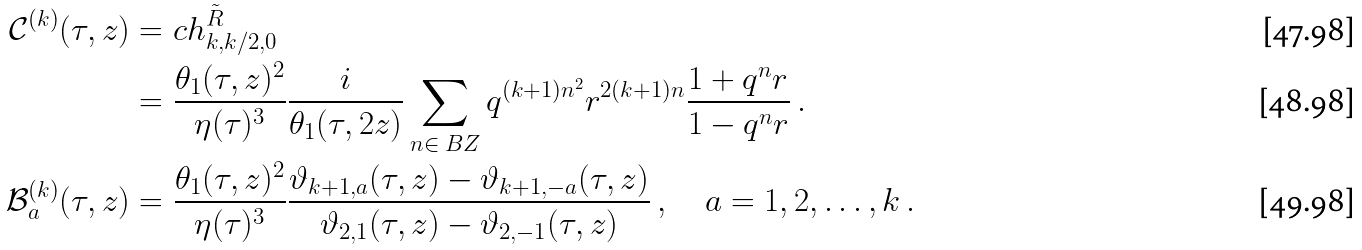Convert formula to latex. <formula><loc_0><loc_0><loc_500><loc_500>\mathcal { C } ^ { ( k ) } ( \tau , z ) & = c h ^ { \tilde { R } } _ { k , k / 2 , 0 } \\ & = \frac { \theta _ { 1 } ( \tau , z ) ^ { 2 } } { \eta ( \tau ) ^ { 3 } } \frac { i } { \theta _ { 1 } ( \tau , 2 z ) } \sum _ { n \in \ B Z } q ^ { ( k + 1 ) n ^ { 2 } } r ^ { 2 ( k + 1 ) n } \frac { 1 + q ^ { n } r } { 1 - q ^ { n } r } \ . \\ \mathcal { B } _ { a } ^ { ( k ) } ( \tau , z ) & = \frac { \theta _ { 1 } ( \tau , z ) ^ { 2 } } { \eta ( \tau ) ^ { 3 } } \frac { \vartheta _ { k + 1 , a } ( \tau , z ) - \vartheta _ { k + 1 , - a } ( \tau , z ) } { \vartheta _ { 2 , 1 } ( \tau , z ) - \vartheta _ { 2 , - 1 } ( \tau , z ) } \ , \quad a = 1 , 2 , \dots , k \ .</formula> 